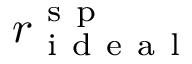<formula> <loc_0><loc_0><loc_500><loc_500>r _ { i d e a l } ^ { s p }</formula> 